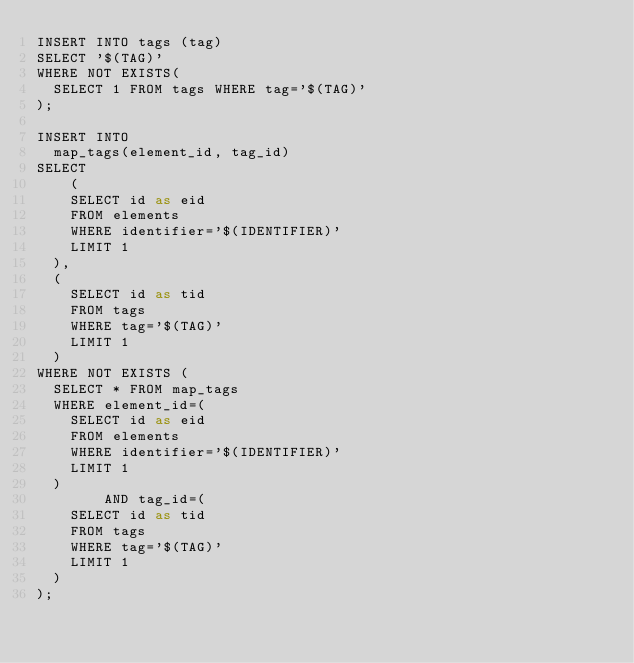<code> <loc_0><loc_0><loc_500><loc_500><_SQL_>INSERT INTO tags (tag)
SELECT '$(TAG)'
WHERE NOT EXISTS(
  SELECT 1 FROM tags WHERE tag='$(TAG)'
);

INSERT INTO
  map_tags(element_id, tag_id)
SELECT
    (
    SELECT id as eid
    FROM elements
    WHERE identifier='$(IDENTIFIER)'
    LIMIT 1
  ),
  (
    SELECT id as tid
    FROM tags
    WHERE tag='$(TAG)'
    LIMIT 1
  )
WHERE NOT EXISTS (
  SELECT * FROM map_tags
  WHERE element_id=(
    SELECT id as eid
    FROM elements
    WHERE identifier='$(IDENTIFIER)'
    LIMIT 1
  )
        AND tag_id=(
    SELECT id as tid
    FROM tags
    WHERE tag='$(TAG)'
    LIMIT 1
  )
);
</code> 